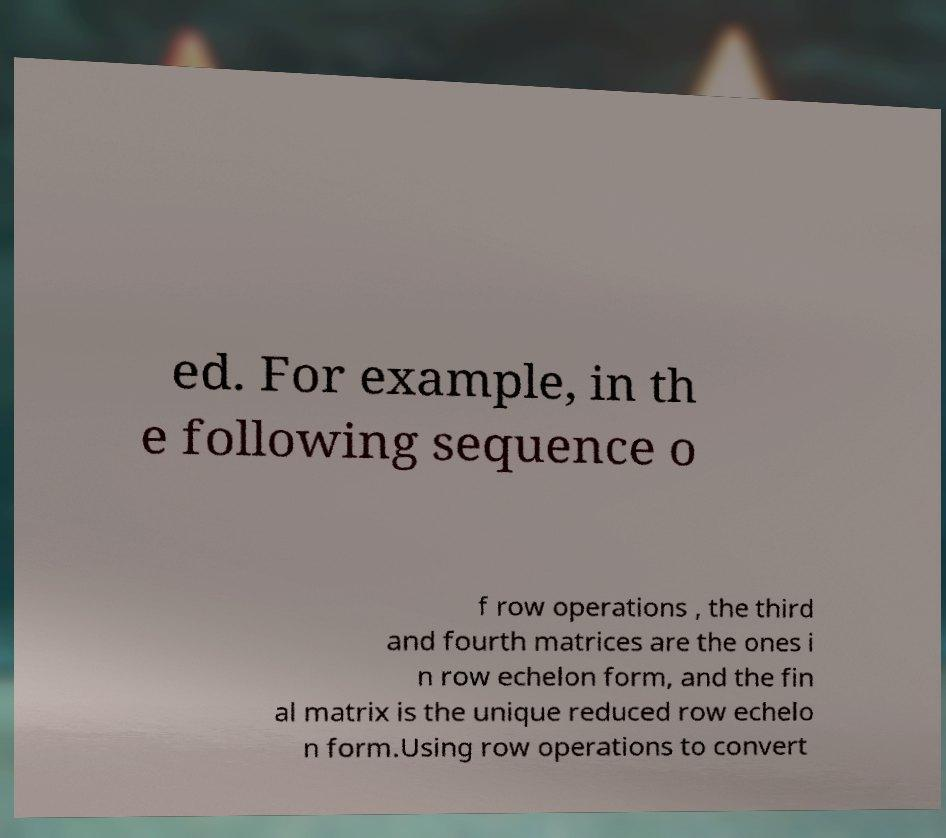Please read and relay the text visible in this image. What does it say? ed. For example, in th e following sequence o f row operations , the third and fourth matrices are the ones i n row echelon form, and the fin al matrix is the unique reduced row echelo n form.Using row operations to convert 